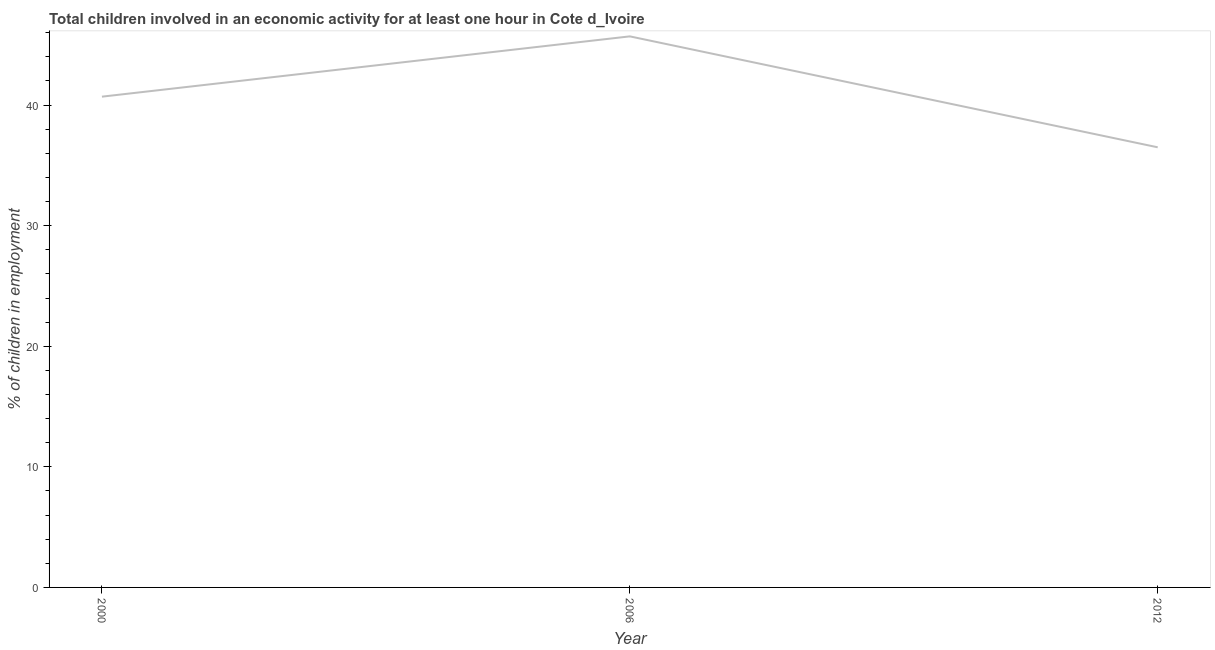What is the percentage of children in employment in 2000?
Make the answer very short. 40.7. Across all years, what is the maximum percentage of children in employment?
Your answer should be compact. 45.7. Across all years, what is the minimum percentage of children in employment?
Your response must be concise. 36.5. In which year was the percentage of children in employment maximum?
Your response must be concise. 2006. In which year was the percentage of children in employment minimum?
Make the answer very short. 2012. What is the sum of the percentage of children in employment?
Your answer should be very brief. 122.9. What is the difference between the percentage of children in employment in 2000 and 2006?
Ensure brevity in your answer.  -5. What is the average percentage of children in employment per year?
Make the answer very short. 40.97. What is the median percentage of children in employment?
Ensure brevity in your answer.  40.7. Do a majority of the years between 2006 and 2012 (inclusive) have percentage of children in employment greater than 18 %?
Offer a very short reply. Yes. What is the ratio of the percentage of children in employment in 2000 to that in 2012?
Offer a terse response. 1.12. Is the difference between the percentage of children in employment in 2000 and 2012 greater than the difference between any two years?
Your answer should be compact. No. What is the difference between the highest and the second highest percentage of children in employment?
Give a very brief answer. 5. What is the difference between the highest and the lowest percentage of children in employment?
Your response must be concise. 9.2. How many lines are there?
Offer a very short reply. 1. How many years are there in the graph?
Your answer should be compact. 3. What is the difference between two consecutive major ticks on the Y-axis?
Your answer should be compact. 10. What is the title of the graph?
Your response must be concise. Total children involved in an economic activity for at least one hour in Cote d_Ivoire. What is the label or title of the Y-axis?
Your response must be concise. % of children in employment. What is the % of children in employment of 2000?
Ensure brevity in your answer.  40.7. What is the % of children in employment in 2006?
Your answer should be compact. 45.7. What is the % of children in employment in 2012?
Provide a short and direct response. 36.5. What is the difference between the % of children in employment in 2000 and 2006?
Your answer should be very brief. -5. What is the ratio of the % of children in employment in 2000 to that in 2006?
Provide a succinct answer. 0.89. What is the ratio of the % of children in employment in 2000 to that in 2012?
Offer a terse response. 1.11. What is the ratio of the % of children in employment in 2006 to that in 2012?
Give a very brief answer. 1.25. 